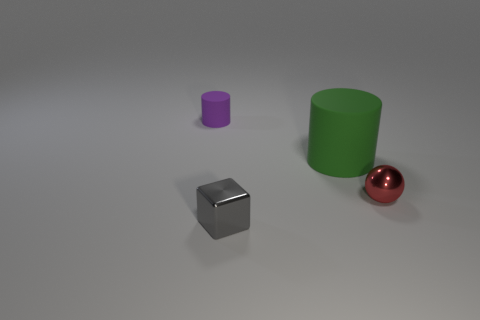Is the small shiny cube the same color as the big rubber thing?
Your response must be concise. No. Is there a big cylinder of the same color as the tiny shiny cube?
Make the answer very short. No. The rubber thing that is the same size as the shiny block is what color?
Provide a short and direct response. Purple. Are there any big rubber objects that have the same shape as the gray shiny thing?
Your answer should be compact. No. Is there a tiny block on the left side of the small metal object that is in front of the small shiny thing that is on the right side of the gray cube?
Offer a terse response. No. What shape is the red metal object that is the same size as the block?
Your answer should be very brief. Sphere. What is the color of the tiny thing that is the same shape as the big green rubber thing?
Your answer should be very brief. Purple. How many things are large matte objects or big brown rubber cylinders?
Offer a terse response. 1. Does the matte thing to the left of the big green object have the same shape as the metallic object on the right side of the green cylinder?
Offer a very short reply. No. There is a small thing right of the big thing; what shape is it?
Offer a very short reply. Sphere. 